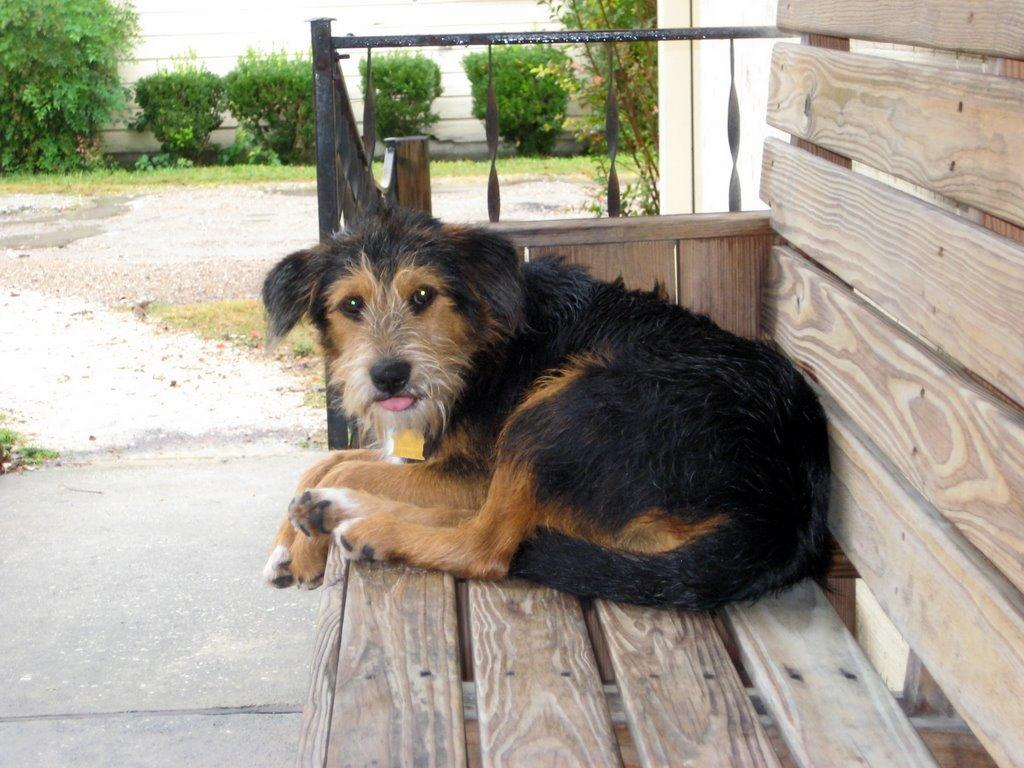What is sitting on the wooden bench in the image? There is a dog on a wooden bench in the image. What type of material is the fence visible in the image made of? The fence visible in the image is made of metal. What type of vegetation can be seen in the image? Plants and grass are visible in the image. What is the background of the image composed of? There is a wall in the image. What type of ink is being used to draw on the dog in the image? There is no ink or drawing present in the image; it is a photograph of a dog sitting on a wooden bench. 